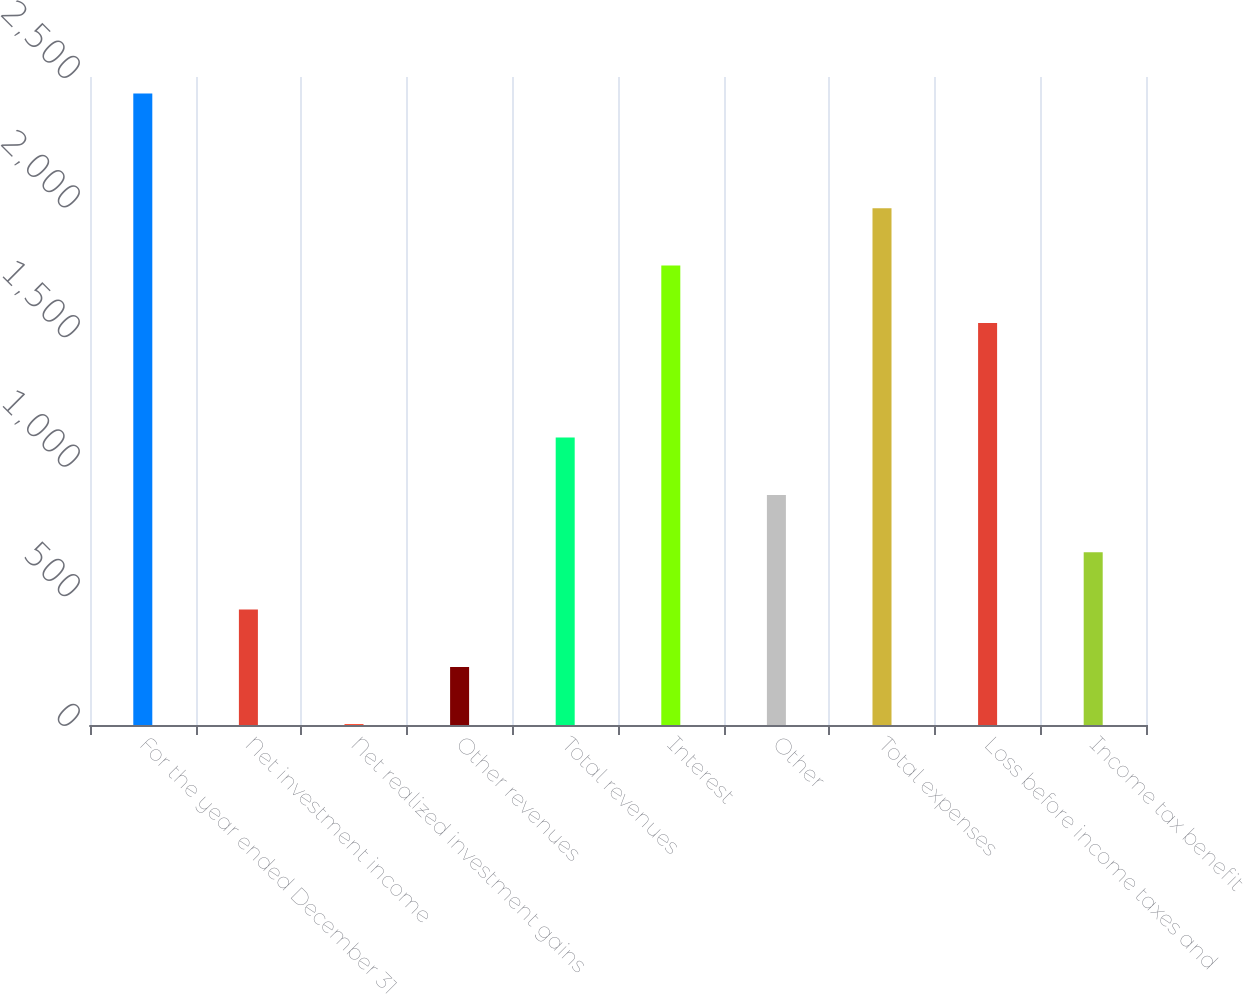<chart> <loc_0><loc_0><loc_500><loc_500><bar_chart><fcel>For the year ended December 31<fcel>Net investment income<fcel>Net realized investment gains<fcel>Other revenues<fcel>Total revenues<fcel>Interest<fcel>Other<fcel>Total expenses<fcel>Loss before income taxes and<fcel>Income tax benefit<nl><fcel>2436.2<fcel>445.4<fcel>3<fcel>224.2<fcel>1109<fcel>1772.6<fcel>887.8<fcel>1993.8<fcel>1551.4<fcel>666.6<nl></chart> 